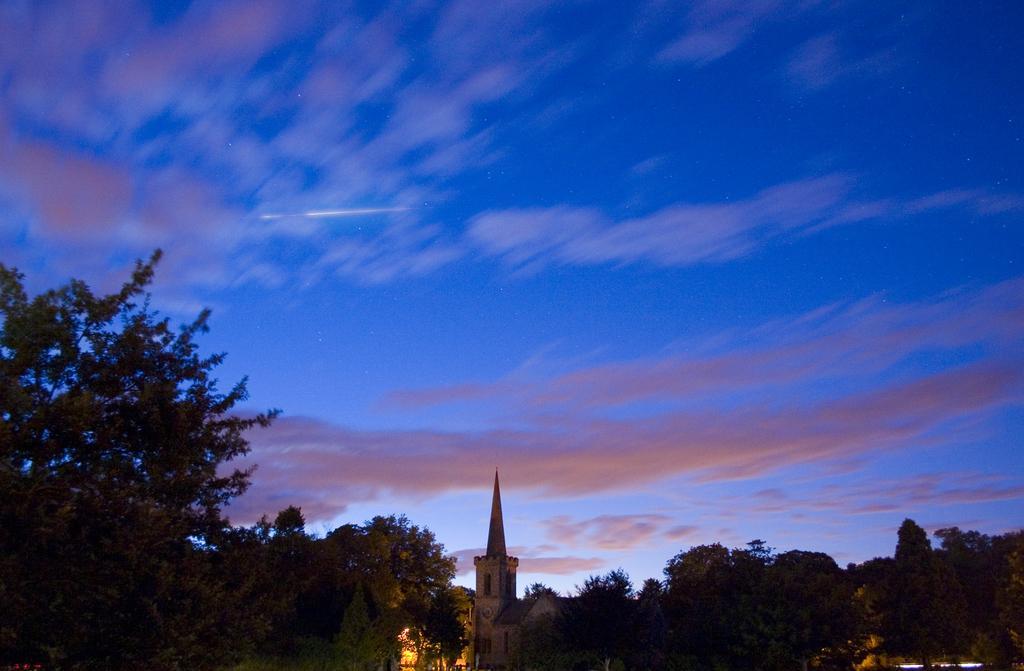Describe this image in one or two sentences. In this image we can see a building, trees and cloudy sky.   